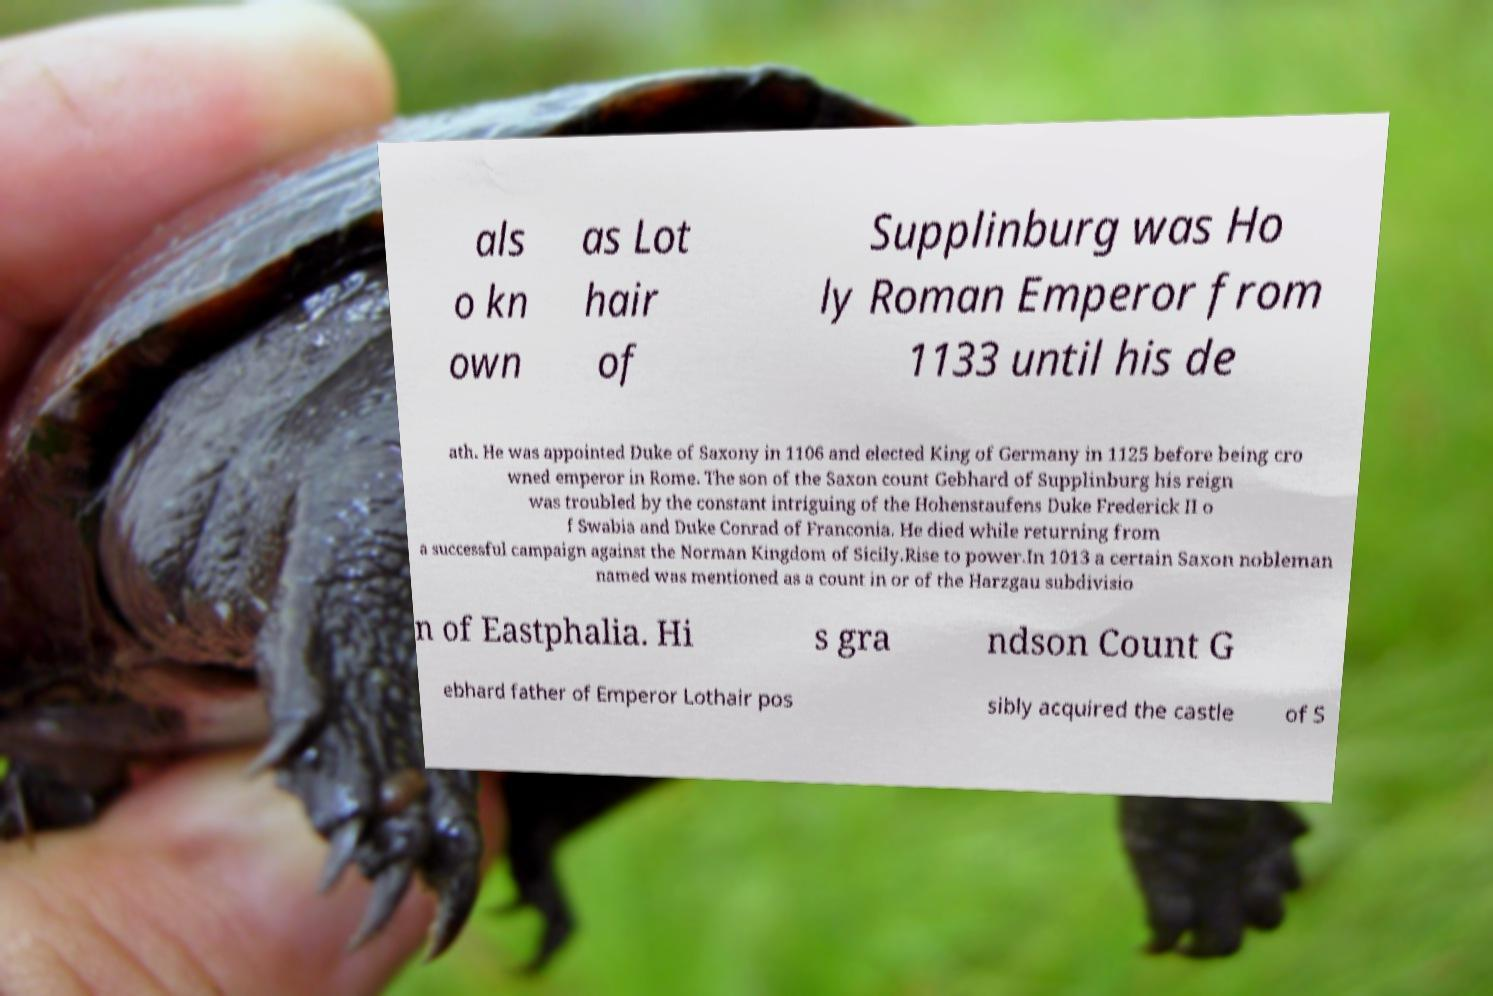What messages or text are displayed in this image? I need them in a readable, typed format. als o kn own as Lot hair of Supplinburg was Ho ly Roman Emperor from 1133 until his de ath. He was appointed Duke of Saxony in 1106 and elected King of Germany in 1125 before being cro wned emperor in Rome. The son of the Saxon count Gebhard of Supplinburg his reign was troubled by the constant intriguing of the Hohenstaufens Duke Frederick II o f Swabia and Duke Conrad of Franconia. He died while returning from a successful campaign against the Norman Kingdom of Sicily.Rise to power.In 1013 a certain Saxon nobleman named was mentioned as a count in or of the Harzgau subdivisio n of Eastphalia. Hi s gra ndson Count G ebhard father of Emperor Lothair pos sibly acquired the castle of S 